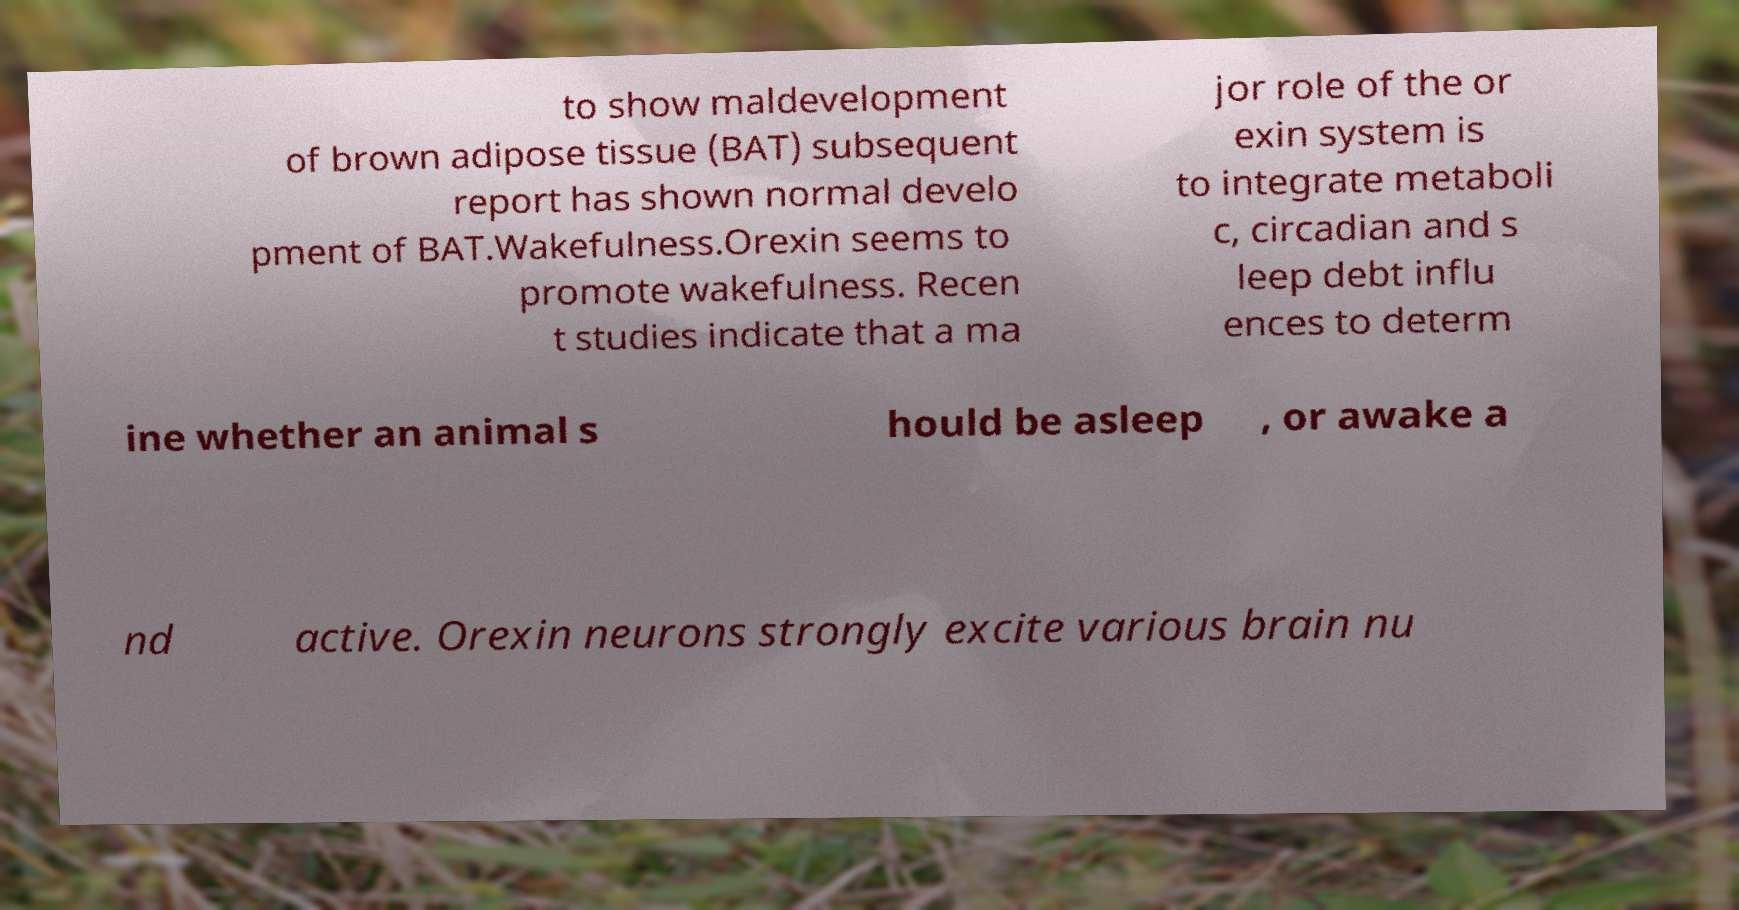Please read and relay the text visible in this image. What does it say? to show maldevelopment of brown adipose tissue (BAT) subsequent report has shown normal develo pment of BAT.Wakefulness.Orexin seems to promote wakefulness. Recen t studies indicate that a ma jor role of the or exin system is to integrate metaboli c, circadian and s leep debt influ ences to determ ine whether an animal s hould be asleep , or awake a nd active. Orexin neurons strongly excite various brain nu 